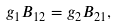<formula> <loc_0><loc_0><loc_500><loc_500>g _ { 1 } B _ { 1 2 } = g _ { 2 } B _ { 2 1 } ,</formula> 